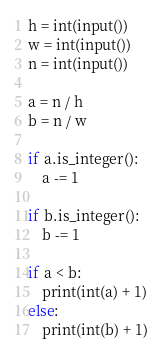Convert code to text. <code><loc_0><loc_0><loc_500><loc_500><_Python_>h = int(input())
w = int(input())
n = int(input())

a = n / h
b = n / w

if a.is_integer():
    a -= 1

if b.is_integer():
    b -= 1

if a < b:
    print(int(a) + 1)
else:
    print(int(b) + 1)</code> 